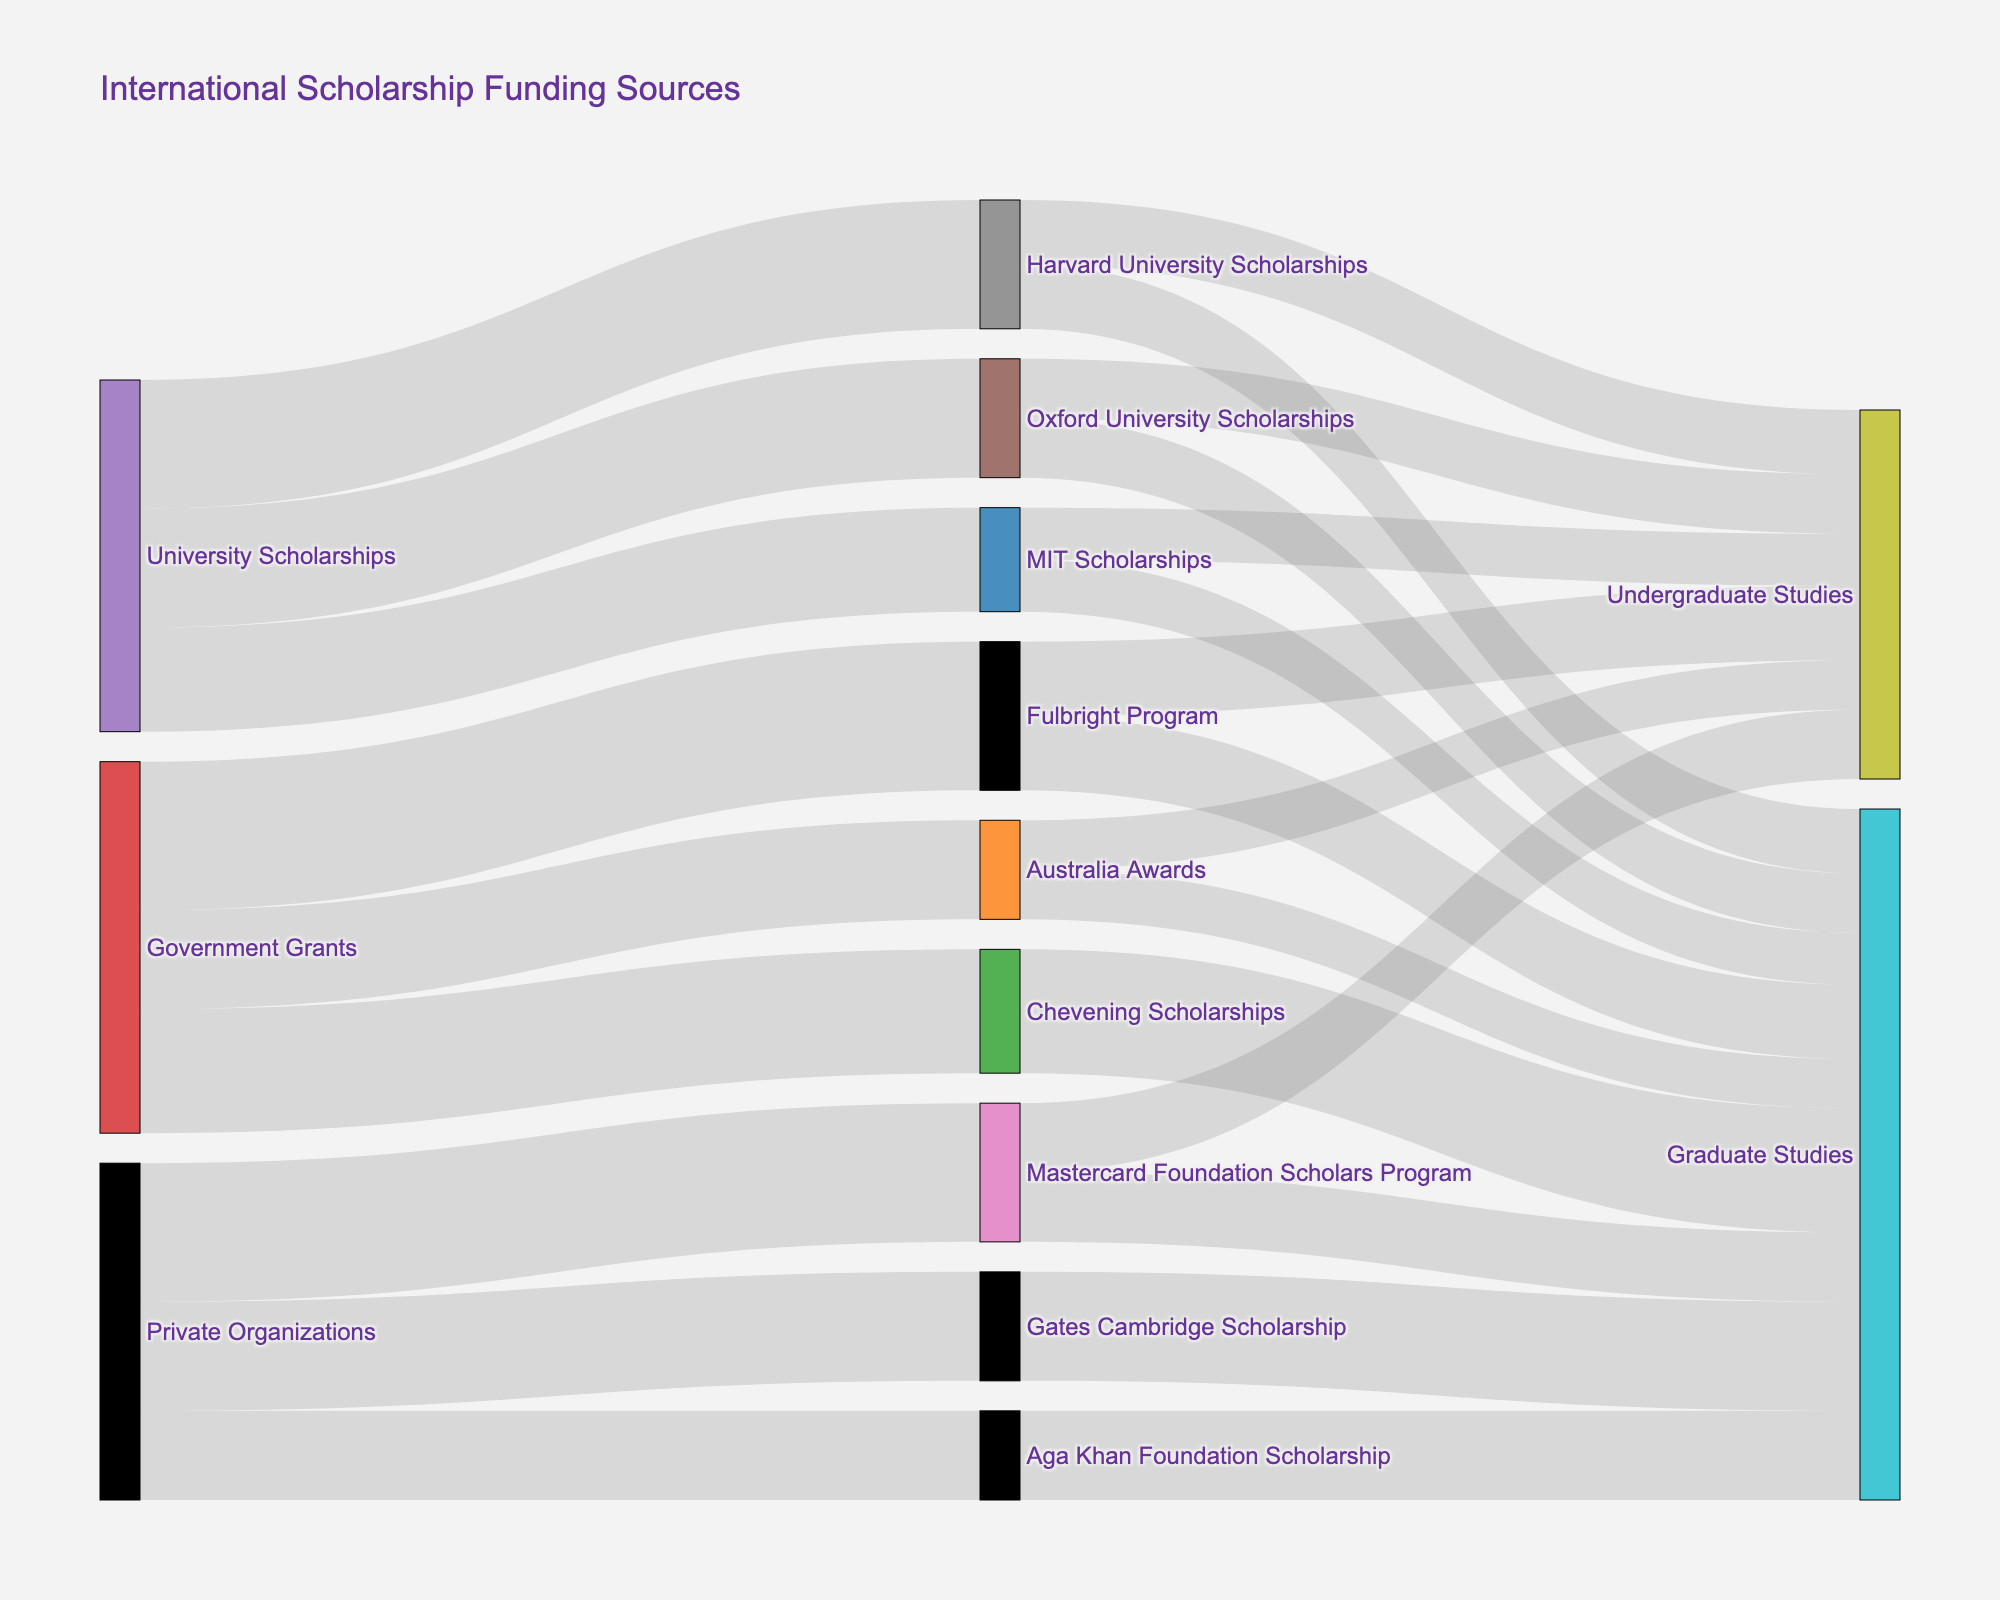What are the different sources of funding highlighted in the diagram? The diagram shows three main funding sources: Government Grants, Private Organizations, and University Scholarships.
Answer: Government Grants, Private Organizations, University Scholarships Which scholarship program receives the highest funding from Government Grants? The Fulbright Program receives the highest funding from Government Grants, with a value of 3000.
Answer: Fulbright Program How many types of scholarships are funded by Private Organizations? There are three types of scholarships funded by Private Organizations: Mastercard Foundation Scholars Program, Gates Cambridge Scholarship, and Aga Khan Foundation Scholarship.
Answer: 3 What is the total funding amount that Government Grants provide? Sum the values for each scholarship under Government Grants: 3000 (Fulbright) + 2500 (Chevening) + 2000 (Australia) = 7500.
Answer: 7500 Which funding source provides more scholarships for undergraduate studies: Government Grants or University Scholarships? From the diagram: Government Grants fund Fulbright (1500) and Australia Awards (1000) for undergraduate studies, total = 2500. University Scholarships fund Harvard (1300), Oxford (1200), and MIT (1050) for undergraduate studies, total = 3550. University Scholarships provide more scholarships for undergraduate studies.
Answer: University Scholarships Among the scholarships provided by Private Organizations, which specific scholarship focuses only on graduate studies? The Gates Cambridge Scholarship and the Aga Khan Foundation Scholarship, both funded by Private Organizations, are solely for graduate studies.
Answer: Gates Cambridge Scholarship, Aga Khan Foundation Scholarship Compare the total funding amounts directed towards undergraduate and graduate studies within University Scholarships. Sum the values for Undergraduate: Harvard (1300) + Oxford (1200) + MIT (1050) = 3550. Sum the values for Graduate: Harvard (1300) + Oxford (1200) + MIT (1050) = 3550. Both receive an equal amount.
Answer: Equal (3550 each) Which specific scholarship program from Private Organizations receives the highest funding? The Mastercard Foundation Scholars Program receives the highest funding from Private Organizations with a value of 2800.
Answer: Mastercard Foundation Scholars Program How does the amount of funding for graduate studies under Government Grants compare to that under Private Organizations? For Government Grants, adding Graduate Studies amounts: Fulbright (1500), Chevening (2500), Australia Awards (1000) total = 5000. For Private Organizations: Mastercard (1400), Gates Cambridge (2200), Aga Khan (1800) total = 5400. Private Organizations provide more for graduate studies.
Answer: Private Organizations Which scholarship program is funded equally for both undergraduate and graduate studies? The Mastercard Foundation Scholars Program is funded equally, with 1400 for Undergraduate Studies and 1400 for Graduate Studies.
Answer: Mastercard Foundation Scholars Program 